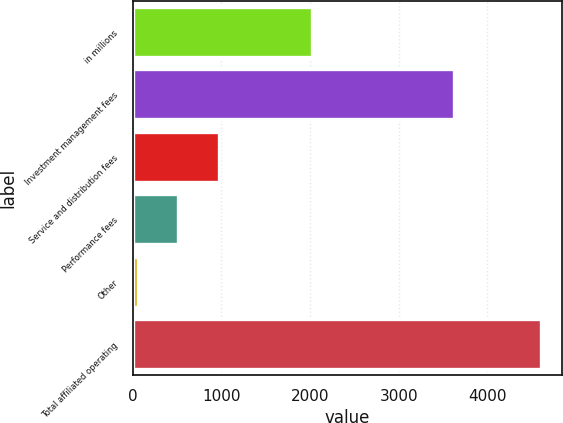Convert chart. <chart><loc_0><loc_0><loc_500><loc_500><bar_chart><fcel>in millions<fcel>Investment management fees<fcel>Service and distribution fees<fcel>Performance fees<fcel>Other<fcel>Total affiliated operating<nl><fcel>2017<fcel>3624.7<fcel>969.04<fcel>514.07<fcel>59.1<fcel>4608.8<nl></chart> 